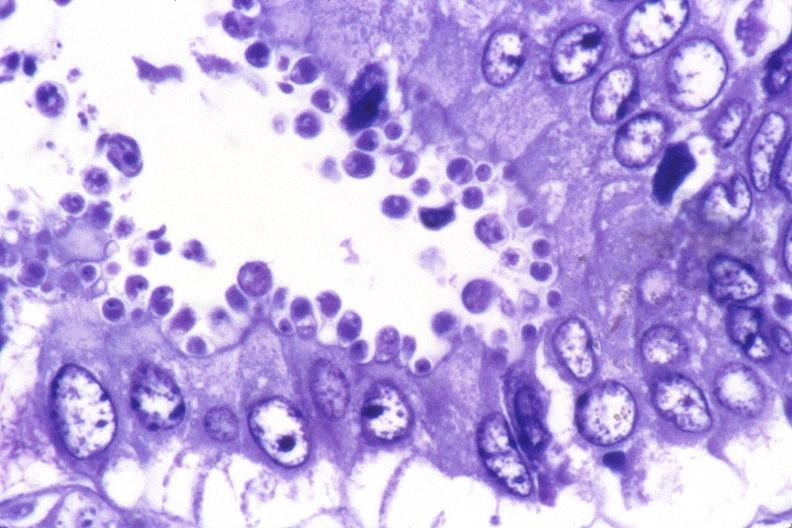s close-up of lesion present?
Answer the question using a single word or phrase. No 